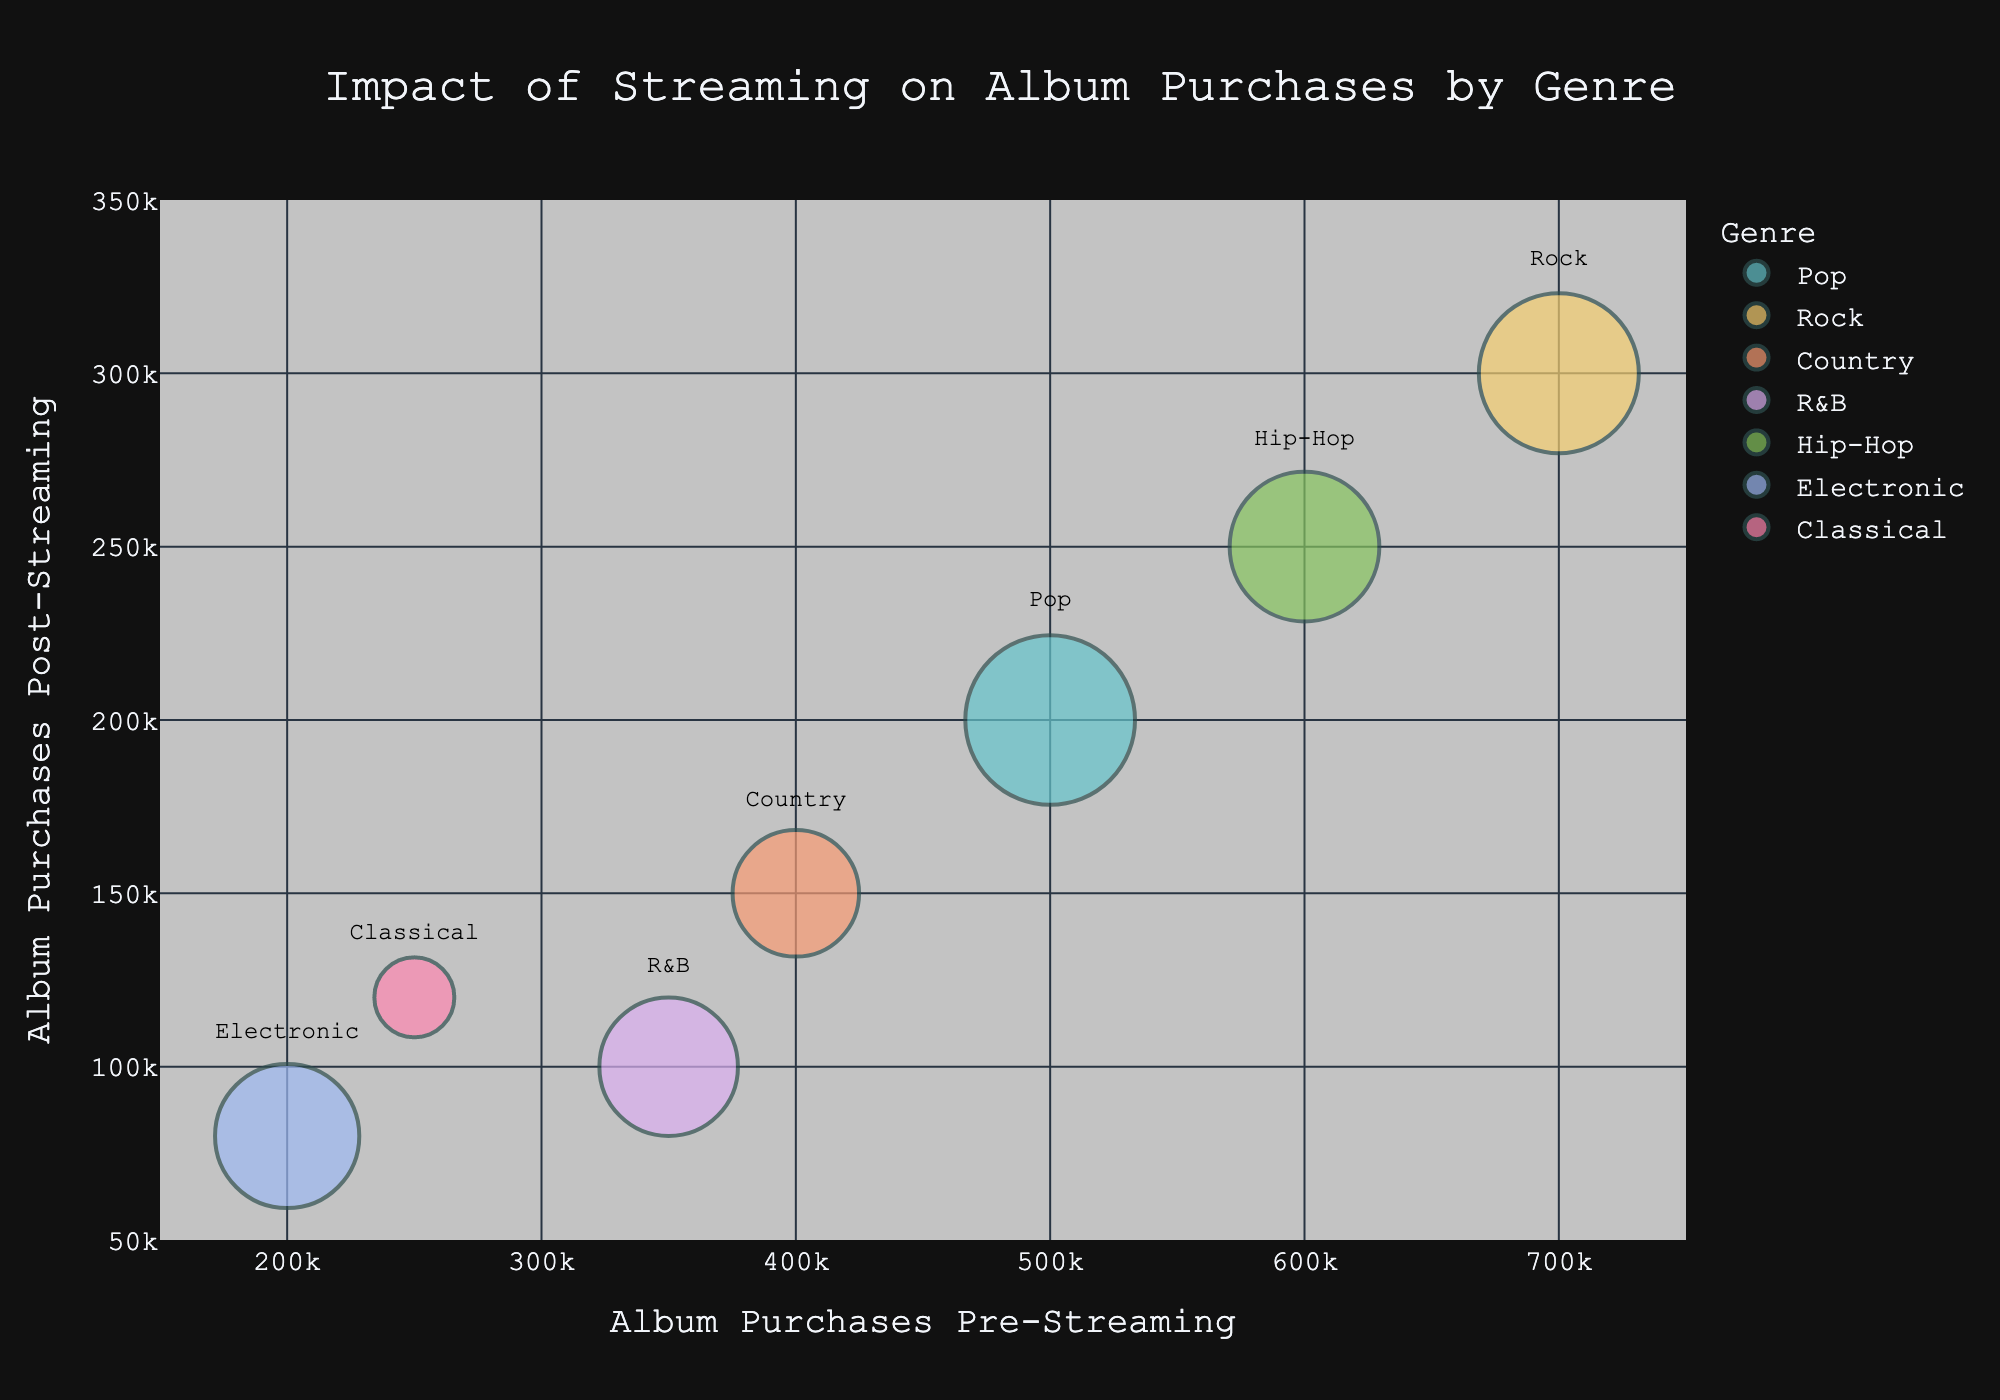What is the title of the bubble chart? The title is usually displayed at the top of the chart, summarizing what the chart represents visually. Here it reads "Impact of Streaming on Album Purchases by Genre".
Answer: Impact of Streaming on Album Purchases by Genre How many music genres are represented in the chart? To determine the number of music genres, count the unique category labels or legend entries corresponding to different bubbles. In this case, there are seven genres: Pop, Rock, Country, R&B, Hip-Hop, Electronic, and Classical.
Answer: 7 Which genre had the highest number of album purchases pre-streaming? By visually scanning the 'Album Purchases Pre-Streaming' axis, the genre with the highest value will be identified. Here, Rock is at 700,000, which is the highest among all genres.
Answer: Rock Which genre has the largest bubble, representing the highest streaming volume? By observing the size of the bubbles, the largest bubble signifies the highest streaming volume. Pop has the largest bubble, indicating 9,000,000 streams.
Answer: Pop Which genre saw the smallest decrease in album purchases post-streaming? By comparing the differences between pre-streaming and post-streaming values for each genre, Classical saw the least decrease from 250,000 to 120,000, which is a decrease of 130,000.
Answer: Classical Are album purchases post-streaming generally higher or lower compared to pre-streaming across all genres? By comparing the positions of all bubbles along the x (pre-streaming) and y (post-streaming) axes, all post-streaming values (y-axis) are lower than their corresponding pre-streaming values (x-axis).
Answer: Lower Which genre's bubble lies closest to the origin (0,0) of the chart? The genre closest to the origin will have the smallest values for pre-streaming and post-streaming purchases. Electronic has the smallest values closest to the origin at (200,000, 80,000).
Answer: Electronic 